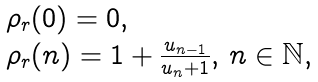Convert formula to latex. <formula><loc_0><loc_0><loc_500><loc_500>\begin{array} { l l } \rho _ { r } ( 0 ) = 0 , \\ \rho _ { r } ( n ) = 1 + \frac { u _ { n - 1 } } { u _ { n } + 1 } , \, n \in \mathbb { N } , \end{array}</formula> 